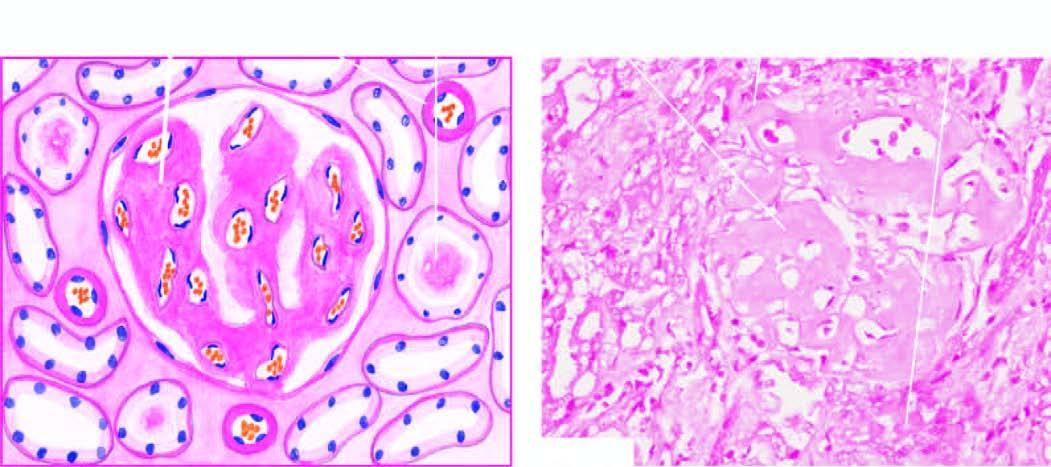what casts in the tubular lumina, and in the arterial wall producing luminal narrowing?
Answer the question using a single word or phrase. Amyloid 